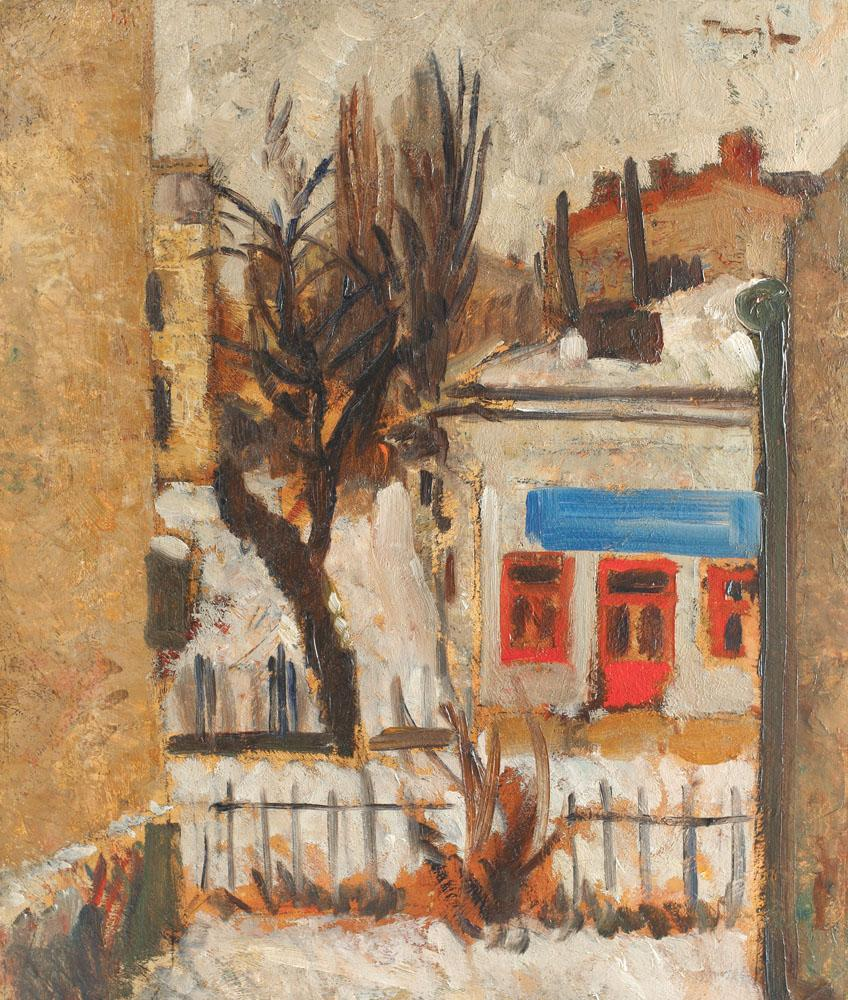What are the key elements in this picture? The image is an oil painting rendered in an impressionist style. It captures a street scene where the most prominent feature is a large tree with bare branches, situated on the left side of the composition. The tree stands in front of a building, its branches partially obscuring the view of the structure. The building itself is characterized by a red window set against a white wall. On the right side of the image, a lamppost can be seen. The color palette of the painting is dominated by earth tones, with the red window providing a striking contrast. The artist's signature is visible in the lower right corner of the painting. The overall impression is one of a quiet, perhaps early morning, scene in a city. 